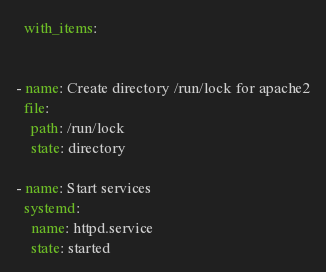Convert code to text. <code><loc_0><loc_0><loc_500><loc_500><_YAML_>  with_items:
  

- name: Create directory /run/lock for apache2
  file: 
    path: /run/lock 
    state: directory

- name: Start services
  systemd: 
    name: httpd.service
    state: started
</code> 